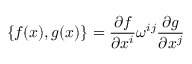<formula> <loc_0><loc_0><loc_500><loc_500>\{ f ( x ) , g ( x ) \} = \frac { \partial f } { \partial x ^ { i } } \omega ^ { i j } \frac { \partial g } { \partial x ^ { j } }</formula> 